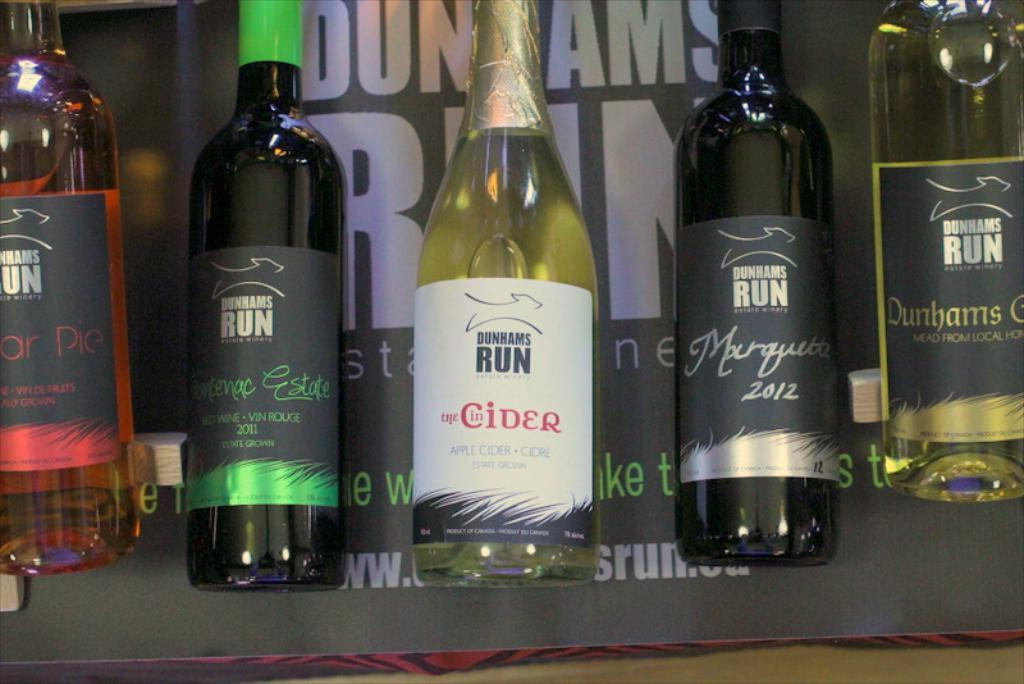<image>
Share a concise interpretation of the image provided. the word Cider is on the front of a bottle 